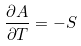Convert formula to latex. <formula><loc_0><loc_0><loc_500><loc_500>\frac { \partial A } { \partial T } = - S</formula> 